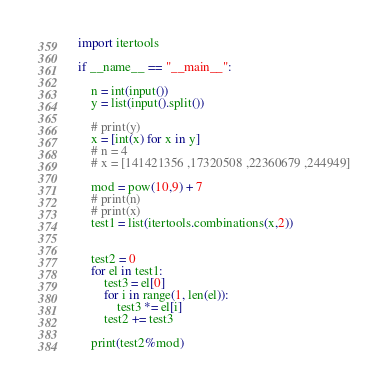Convert code to text. <code><loc_0><loc_0><loc_500><loc_500><_Python_>import itertools

if __name__ == "__main__":

    n = int(input())
    y = list(input().split())

    # print(y)
    x = [int(x) for x in y]
    # n = 4
    # x = [141421356 ,17320508 ,22360679 ,244949]

    mod = pow(10,9) + 7
    # print(n)
    # print(x)
    test1 = list(itertools.combinations(x,2))


    test2 = 0
    for el in test1:
        test3 = el[0]
        for i in range(1, len(el)):
            test3 *= el[i]
        test2 += test3

    print(test2%mod)
</code> 